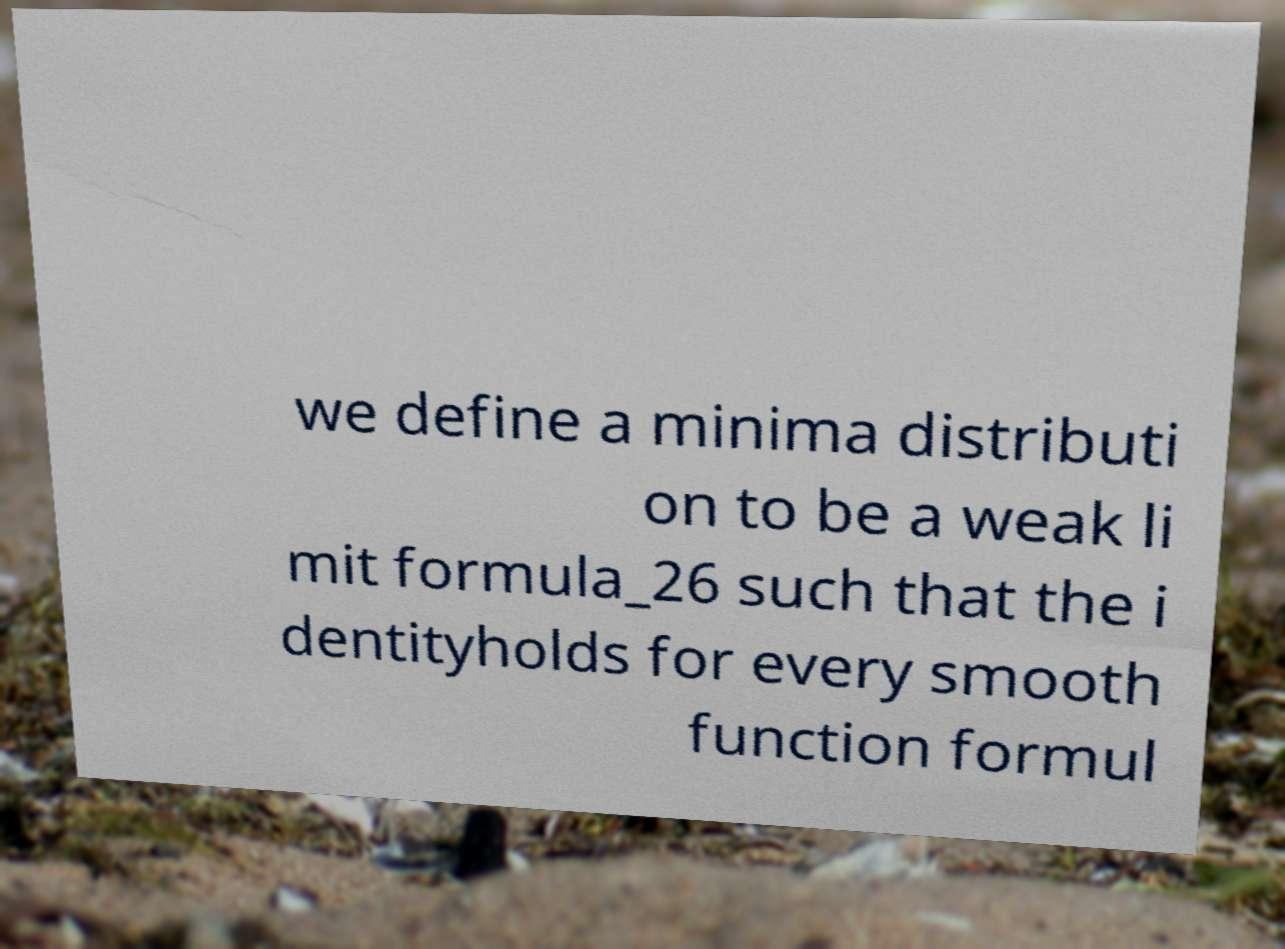Can you read and provide the text displayed in the image?This photo seems to have some interesting text. Can you extract and type it out for me? we define a minima distributi on to be a weak li mit formula_26 such that the i dentityholds for every smooth function formul 